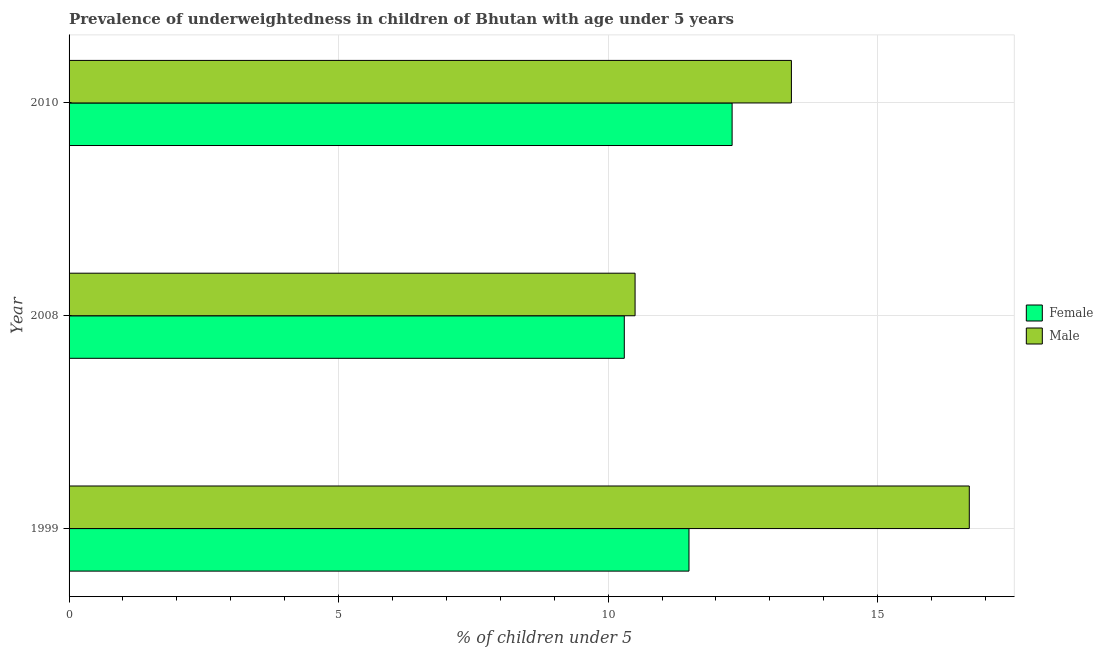Are the number of bars per tick equal to the number of legend labels?
Ensure brevity in your answer.  Yes. Are the number of bars on each tick of the Y-axis equal?
Provide a succinct answer. Yes. What is the label of the 3rd group of bars from the top?
Give a very brief answer. 1999. In how many cases, is the number of bars for a given year not equal to the number of legend labels?
Your response must be concise. 0. What is the percentage of underweighted male children in 2010?
Give a very brief answer. 13.4. Across all years, what is the maximum percentage of underweighted female children?
Keep it short and to the point. 12.3. Across all years, what is the minimum percentage of underweighted male children?
Make the answer very short. 10.5. In which year was the percentage of underweighted female children maximum?
Give a very brief answer. 2010. What is the total percentage of underweighted female children in the graph?
Provide a succinct answer. 34.1. What is the difference between the percentage of underweighted male children in 2010 and the percentage of underweighted female children in 1999?
Provide a succinct answer. 1.9. What is the average percentage of underweighted female children per year?
Provide a succinct answer. 11.37. In the year 2008, what is the difference between the percentage of underweighted male children and percentage of underweighted female children?
Keep it short and to the point. 0.2. What is the ratio of the percentage of underweighted female children in 1999 to that in 2008?
Keep it short and to the point. 1.12. Is the difference between the percentage of underweighted male children in 1999 and 2008 greater than the difference between the percentage of underweighted female children in 1999 and 2008?
Ensure brevity in your answer.  Yes. What is the difference between the highest and the lowest percentage of underweighted female children?
Offer a very short reply. 2. In how many years, is the percentage of underweighted female children greater than the average percentage of underweighted female children taken over all years?
Offer a terse response. 2. Is the sum of the percentage of underweighted male children in 2008 and 2010 greater than the maximum percentage of underweighted female children across all years?
Provide a short and direct response. Yes. Are all the bars in the graph horizontal?
Provide a succinct answer. Yes. Are the values on the major ticks of X-axis written in scientific E-notation?
Offer a terse response. No. Does the graph contain any zero values?
Offer a very short reply. No. Does the graph contain grids?
Offer a very short reply. Yes. Where does the legend appear in the graph?
Make the answer very short. Center right. How many legend labels are there?
Your answer should be compact. 2. How are the legend labels stacked?
Provide a short and direct response. Vertical. What is the title of the graph?
Ensure brevity in your answer.  Prevalence of underweightedness in children of Bhutan with age under 5 years. What is the label or title of the X-axis?
Your answer should be compact.  % of children under 5. What is the  % of children under 5 of Male in 1999?
Provide a succinct answer. 16.7. What is the  % of children under 5 of Female in 2008?
Provide a succinct answer. 10.3. What is the  % of children under 5 in Female in 2010?
Keep it short and to the point. 12.3. What is the  % of children under 5 of Male in 2010?
Provide a succinct answer. 13.4. Across all years, what is the maximum  % of children under 5 of Female?
Provide a succinct answer. 12.3. Across all years, what is the maximum  % of children under 5 of Male?
Your response must be concise. 16.7. Across all years, what is the minimum  % of children under 5 of Female?
Your answer should be compact. 10.3. Across all years, what is the minimum  % of children under 5 in Male?
Your answer should be very brief. 10.5. What is the total  % of children under 5 of Female in the graph?
Give a very brief answer. 34.1. What is the total  % of children under 5 of Male in the graph?
Provide a succinct answer. 40.6. What is the difference between the  % of children under 5 in Female in 1999 and that in 2008?
Make the answer very short. 1.2. What is the difference between the  % of children under 5 in Male in 1999 and that in 2008?
Provide a short and direct response. 6.2. What is the difference between the  % of children under 5 in Female in 1999 and that in 2010?
Give a very brief answer. -0.8. What is the difference between the  % of children under 5 of Male in 1999 and that in 2010?
Keep it short and to the point. 3.3. What is the difference between the  % of children under 5 in Female in 2008 and that in 2010?
Make the answer very short. -2. What is the difference between the  % of children under 5 of Male in 2008 and that in 2010?
Your response must be concise. -2.9. What is the difference between the  % of children under 5 of Female in 1999 and the  % of children under 5 of Male in 2010?
Offer a terse response. -1.9. What is the average  % of children under 5 in Female per year?
Your response must be concise. 11.37. What is the average  % of children under 5 in Male per year?
Make the answer very short. 13.53. In the year 2010, what is the difference between the  % of children under 5 of Female and  % of children under 5 of Male?
Offer a terse response. -1.1. What is the ratio of the  % of children under 5 of Female in 1999 to that in 2008?
Keep it short and to the point. 1.12. What is the ratio of the  % of children under 5 of Male in 1999 to that in 2008?
Provide a short and direct response. 1.59. What is the ratio of the  % of children under 5 in Female in 1999 to that in 2010?
Offer a very short reply. 0.94. What is the ratio of the  % of children under 5 in Male in 1999 to that in 2010?
Your response must be concise. 1.25. What is the ratio of the  % of children under 5 of Female in 2008 to that in 2010?
Provide a succinct answer. 0.84. What is the ratio of the  % of children under 5 in Male in 2008 to that in 2010?
Your answer should be compact. 0.78. What is the difference between the highest and the second highest  % of children under 5 in Female?
Your answer should be compact. 0.8. What is the difference between the highest and the second highest  % of children under 5 of Male?
Make the answer very short. 3.3. What is the difference between the highest and the lowest  % of children under 5 of Female?
Your response must be concise. 2. What is the difference between the highest and the lowest  % of children under 5 in Male?
Your answer should be compact. 6.2. 